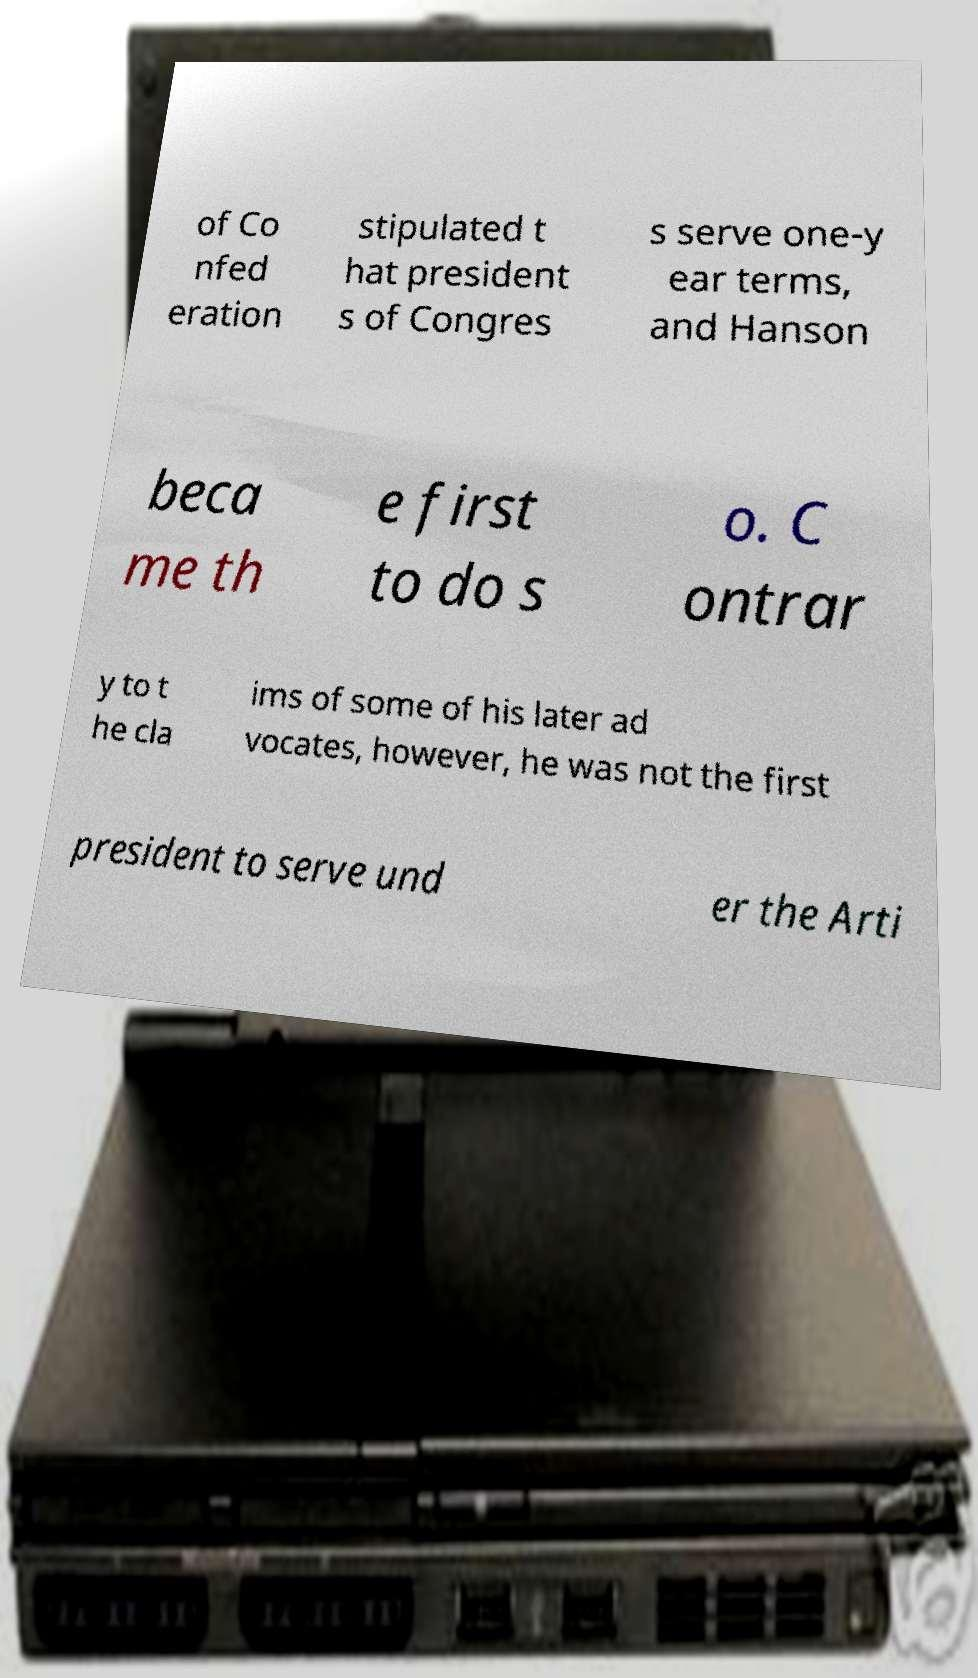Please read and relay the text visible in this image. What does it say? of Co nfed eration stipulated t hat president s of Congres s serve one-y ear terms, and Hanson beca me th e first to do s o. C ontrar y to t he cla ims of some of his later ad vocates, however, he was not the first president to serve und er the Arti 